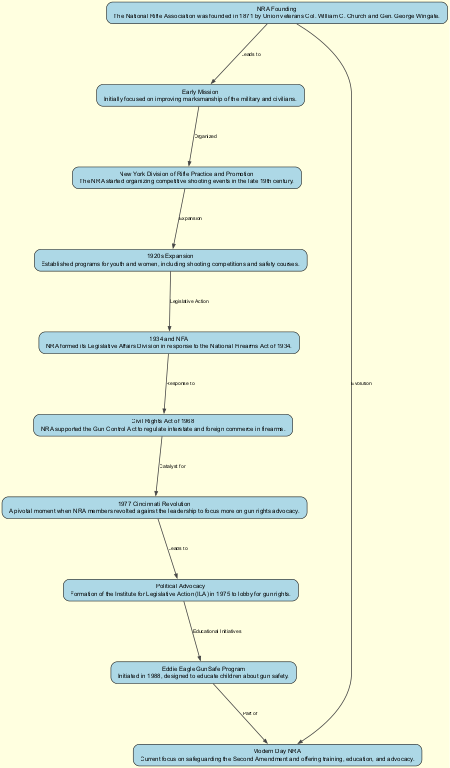What year was the NRA founded? The diagram indicates that the NRA was founded in 1871. This information is specifically detailed in the node labeled "NRA Founding."
Answer: 1871 What relationship exists between "1920s Expansion" and "Civil Rights Act of 1968"? The diagram shows that "1920s Expansion" leads to "Legislative Action," which then eventually connects to the "Civil Rights Act of 1968." Thus, the connection flows through the Legislative Action phase.
Answer: Legislative Action How many total nodes are presented in the diagram? By counting the node entries listed, there are ten distinct nodes included in the diagram related to the history and evolution of the NRA.
Answer: 10 What preceded the "1977 Cincinnati Revolution"? According to the diagram, before the "1977 Cincinnati Revolution," the "Civil Rights Act of 1968" served as a catalyst that prompted members to take action, highlighting a tension in the NRA's direction.
Answer: Civil Rights Act of 1968 What is the main focus of the "Modern Day NRA"? The diagram specifies that the current focus of the "Modern Day NRA" is on safeguarding the Second Amendment, providing training, education, and advocacy. This is indicated in the last node connected directly to the founding.
Answer: Safeguarding the Second Amendment What educational initiative is associated with the NRA in 1988? The diagram notes that the "Eddie Eagle GunSafe Program" was initiated in 1988, specifically designed to educate children about gun safety.
Answer: Eddie Eagle GunSafe Program Which node connects both the "NRA Founding" and "Modern Day NRA"? The diagram illustrates a direct edge labeled "Evolution" from "NRA Founding" to "Modern Day NRA." This signifies that the evolution over time directly links these two concepts.
Answer: Evolution What led to the initiation of the "Institute for Legislative Action"? The "1977 Cincinnati Revolution" is noted in the diagram as the event that led to the formation of the Institute for Legislative Action, indicating a pivotal shift within the organization towards more active political advocacy.
Answer: 1977 Cincinnati Revolution How does "New York Division of Rifle Practice and Promotion" relate to "Early Mission"? The diagram shows a direct link indicating that the "Early Mission" of improving marksmanship organized the "New York Division of Rifle Practice and Promotion," indicating that initial objectives laid the groundwork for this division.
Answer: Organized 